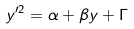Convert formula to latex. <formula><loc_0><loc_0><loc_500><loc_500>y ^ { \prime 2 } = \alpha + \beta y + \Gamma</formula> 